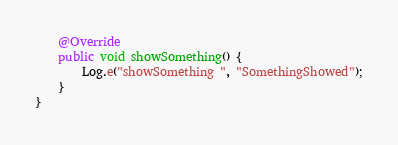<code> <loc_0><loc_0><loc_500><loc_500><_Java_>    @Override
    public void showSomething() {
        Log.e("showSomething ", "SomethingShowed");
    }
}
</code> 